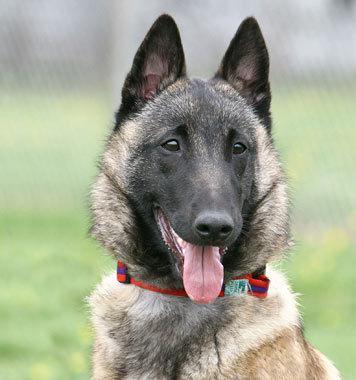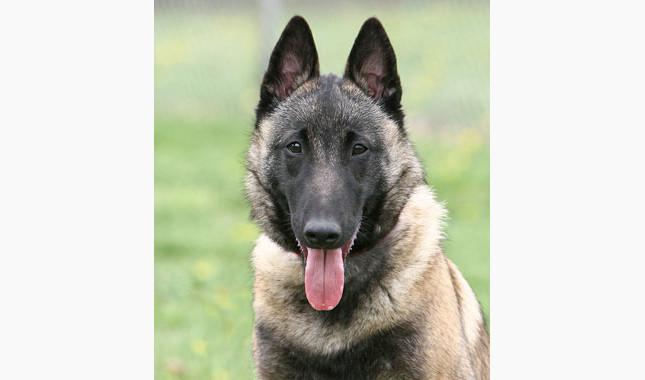The first image is the image on the left, the second image is the image on the right. Considering the images on both sides, is "All dogs have their tongue sticking out." valid? Answer yes or no. Yes. 